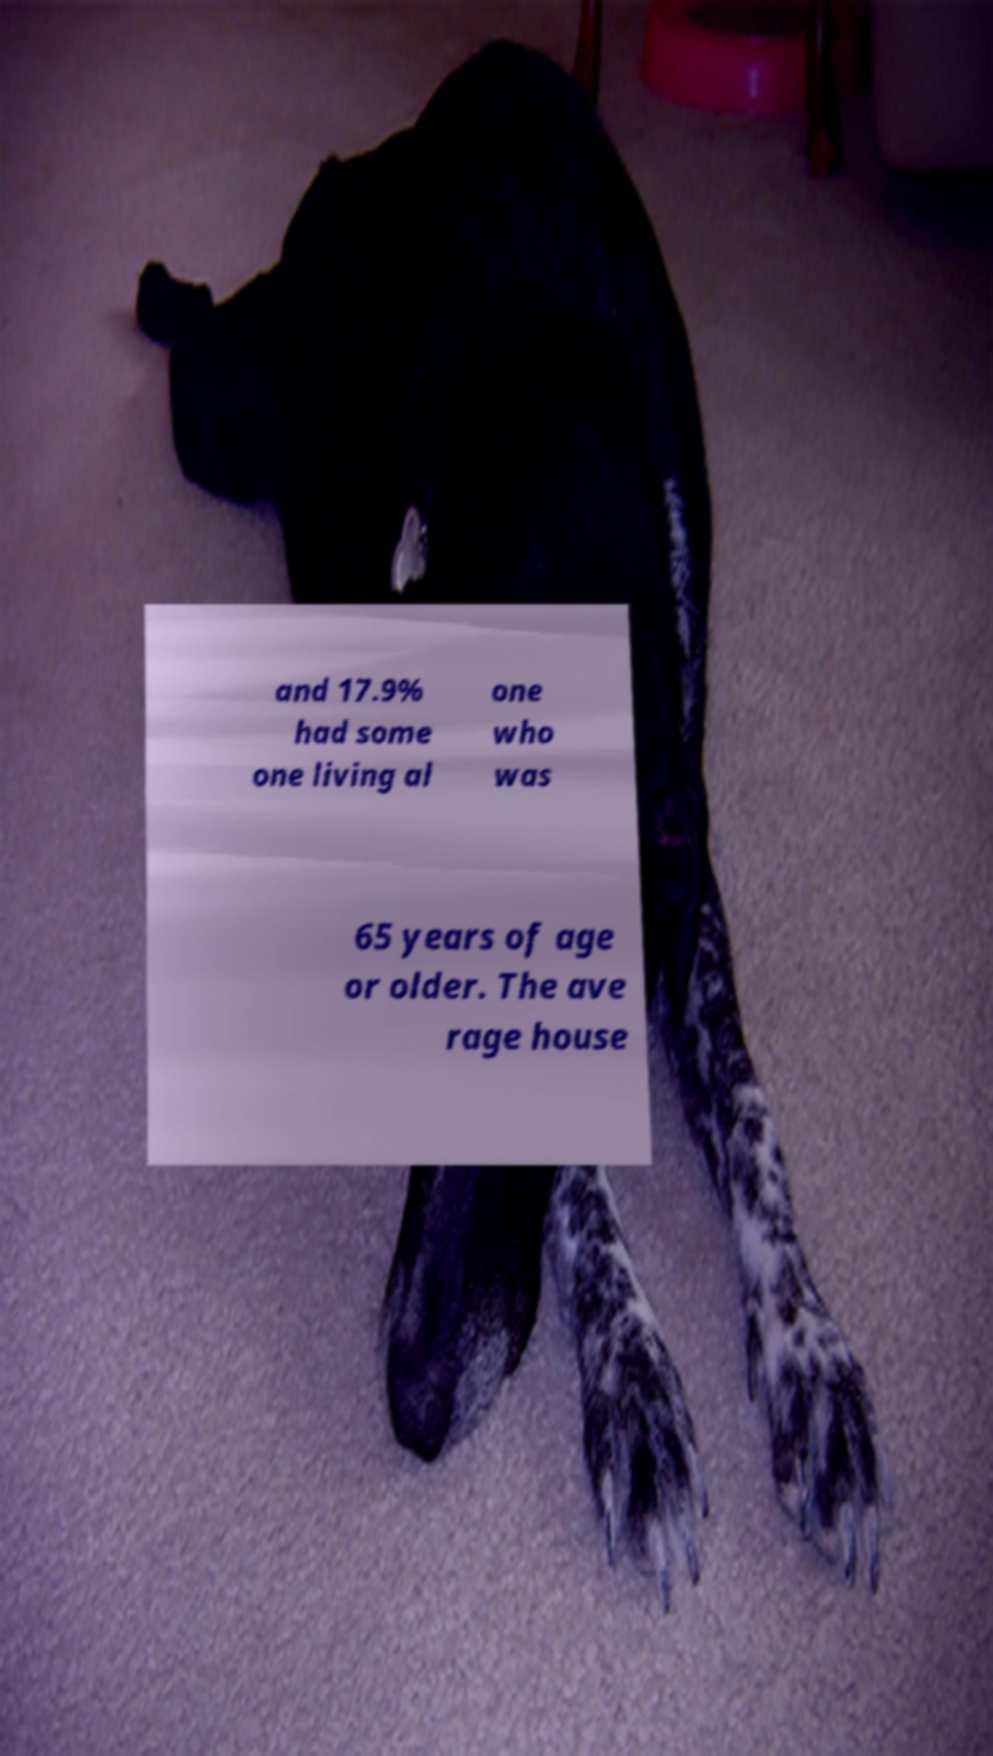I need the written content from this picture converted into text. Can you do that? and 17.9% had some one living al one who was 65 years of age or older. The ave rage house 